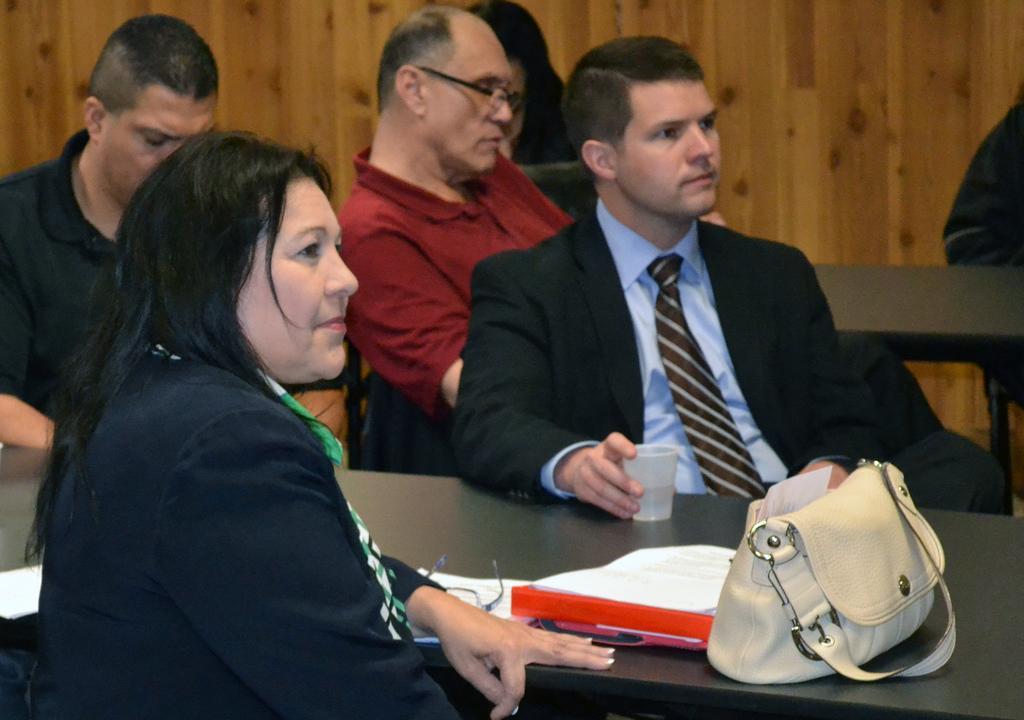Can you describe this image briefly? In this picture there are group of people sitting on the chair. There is a cup, spectacle , file, paper, handbag on the table. 